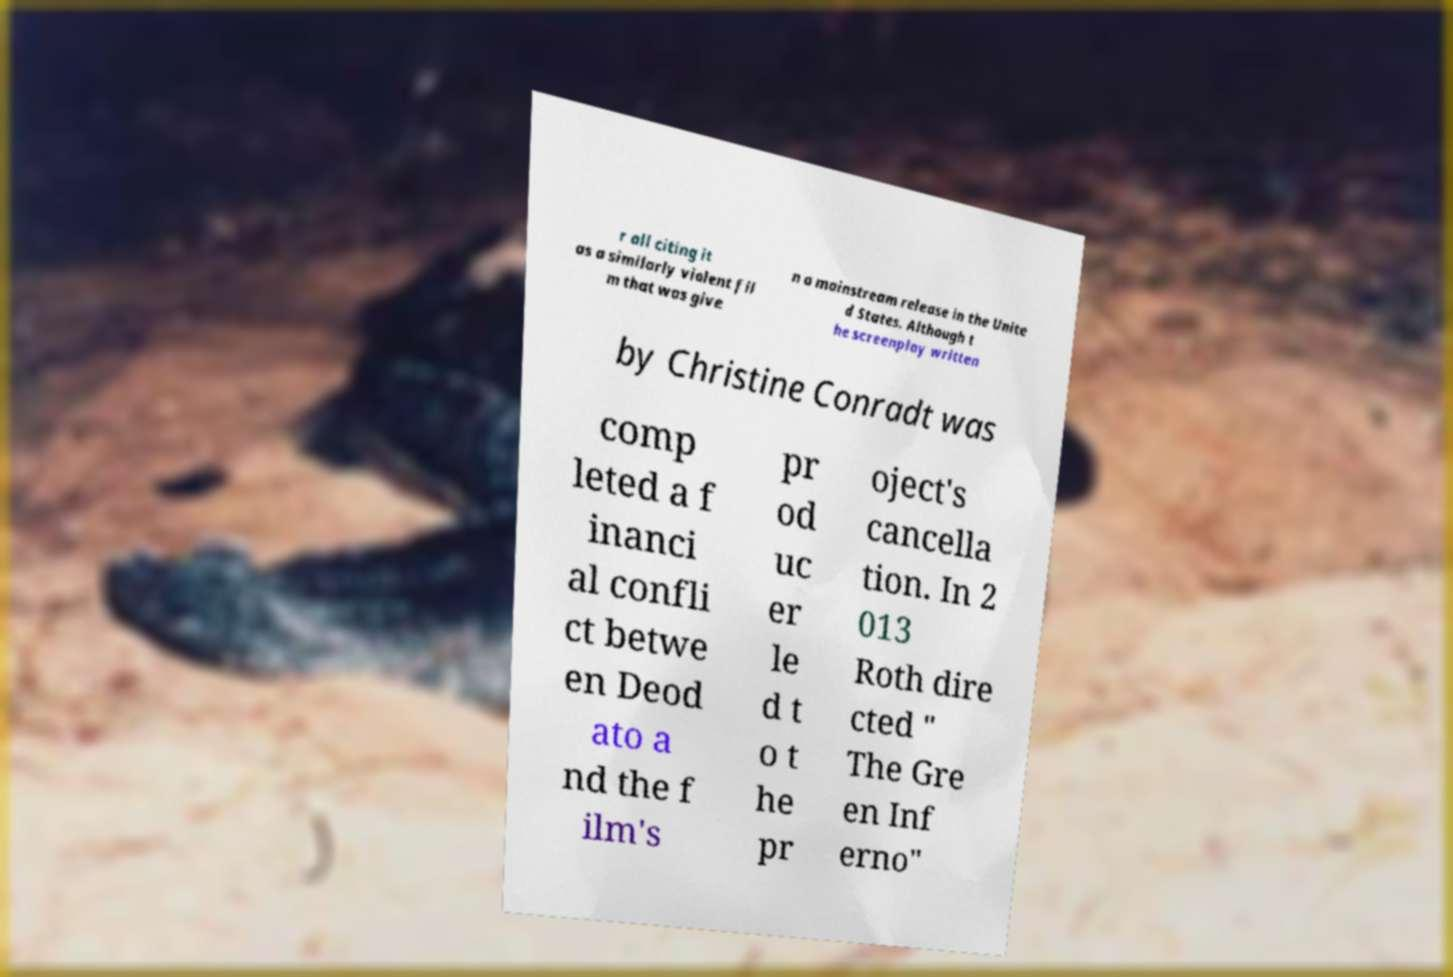There's text embedded in this image that I need extracted. Can you transcribe it verbatim? r all citing it as a similarly violent fil m that was give n a mainstream release in the Unite d States. Although t he screenplay written by Christine Conradt was comp leted a f inanci al confli ct betwe en Deod ato a nd the f ilm's pr od uc er le d t o t he pr oject's cancella tion. In 2 013 Roth dire cted " The Gre en Inf erno" 